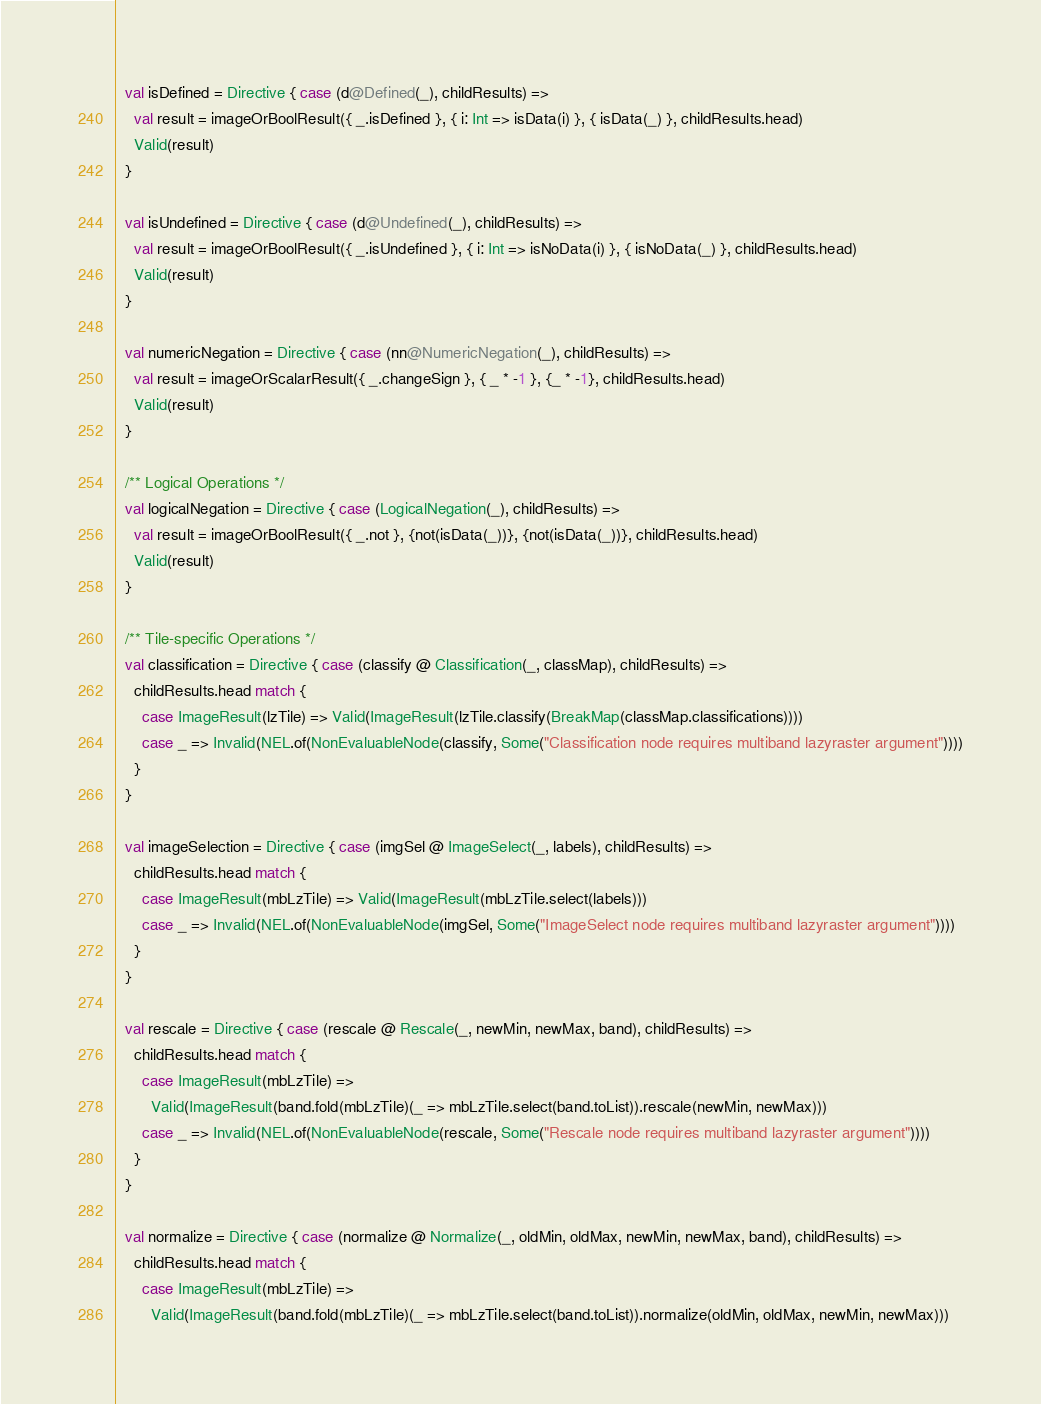<code> <loc_0><loc_0><loc_500><loc_500><_Scala_>
  val isDefined = Directive { case (d@Defined(_), childResults) =>
    val result = imageOrBoolResult({ _.isDefined }, { i: Int => isData(i) }, { isData(_) }, childResults.head)
    Valid(result)
  }

  val isUndefined = Directive { case (d@Undefined(_), childResults) =>
    val result = imageOrBoolResult({ _.isUndefined }, { i: Int => isNoData(i) }, { isNoData(_) }, childResults.head)
    Valid(result)
  }

  val numericNegation = Directive { case (nn@NumericNegation(_), childResults) =>
    val result = imageOrScalarResult({ _.changeSign }, { _ * -1 }, {_ * -1}, childResults.head)
    Valid(result)
  }

  /** Logical Operations */
  val logicalNegation = Directive { case (LogicalNegation(_), childResults) =>
    val result = imageOrBoolResult({ _.not }, {not(isData(_))}, {not(isData(_))}, childResults.head)
    Valid(result)
  }

  /** Tile-specific Operations */
  val classification = Directive { case (classify @ Classification(_, classMap), childResults) =>
    childResults.head match {
      case ImageResult(lzTile) => Valid(ImageResult(lzTile.classify(BreakMap(classMap.classifications))))
      case _ => Invalid(NEL.of(NonEvaluableNode(classify, Some("Classification node requires multiband lazyraster argument"))))
    }
  }

  val imageSelection = Directive { case (imgSel @ ImageSelect(_, labels), childResults) =>
    childResults.head match {
      case ImageResult(mbLzTile) => Valid(ImageResult(mbLzTile.select(labels)))
      case _ => Invalid(NEL.of(NonEvaluableNode(imgSel, Some("ImageSelect node requires multiband lazyraster argument"))))
    }
  }

  val rescale = Directive { case (rescale @ Rescale(_, newMin, newMax, band), childResults) =>
    childResults.head match {
      case ImageResult(mbLzTile) =>
        Valid(ImageResult(band.fold(mbLzTile)(_ => mbLzTile.select(band.toList)).rescale(newMin, newMax)))
      case _ => Invalid(NEL.of(NonEvaluableNode(rescale, Some("Rescale node requires multiband lazyraster argument"))))
    }
  }

  val normalize = Directive { case (normalize @ Normalize(_, oldMin, oldMax, newMin, newMax, band), childResults) =>
    childResults.head match {
      case ImageResult(mbLzTile) =>
        Valid(ImageResult(band.fold(mbLzTile)(_ => mbLzTile.select(band.toList)).normalize(oldMin, oldMax, newMin, newMax)))</code> 